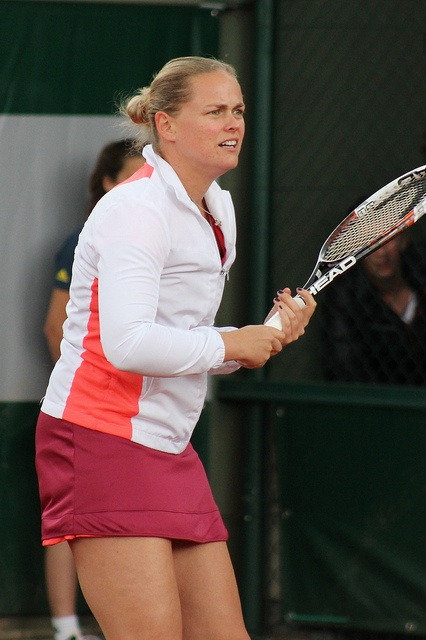Describe the objects in this image and their specific colors. I can see people in black, lightgray, salmon, brown, and tan tones, people in black, maroon, gray, and brown tones, tennis racket in black, lightgray, darkgray, and gray tones, and people in black and brown tones in this image. 